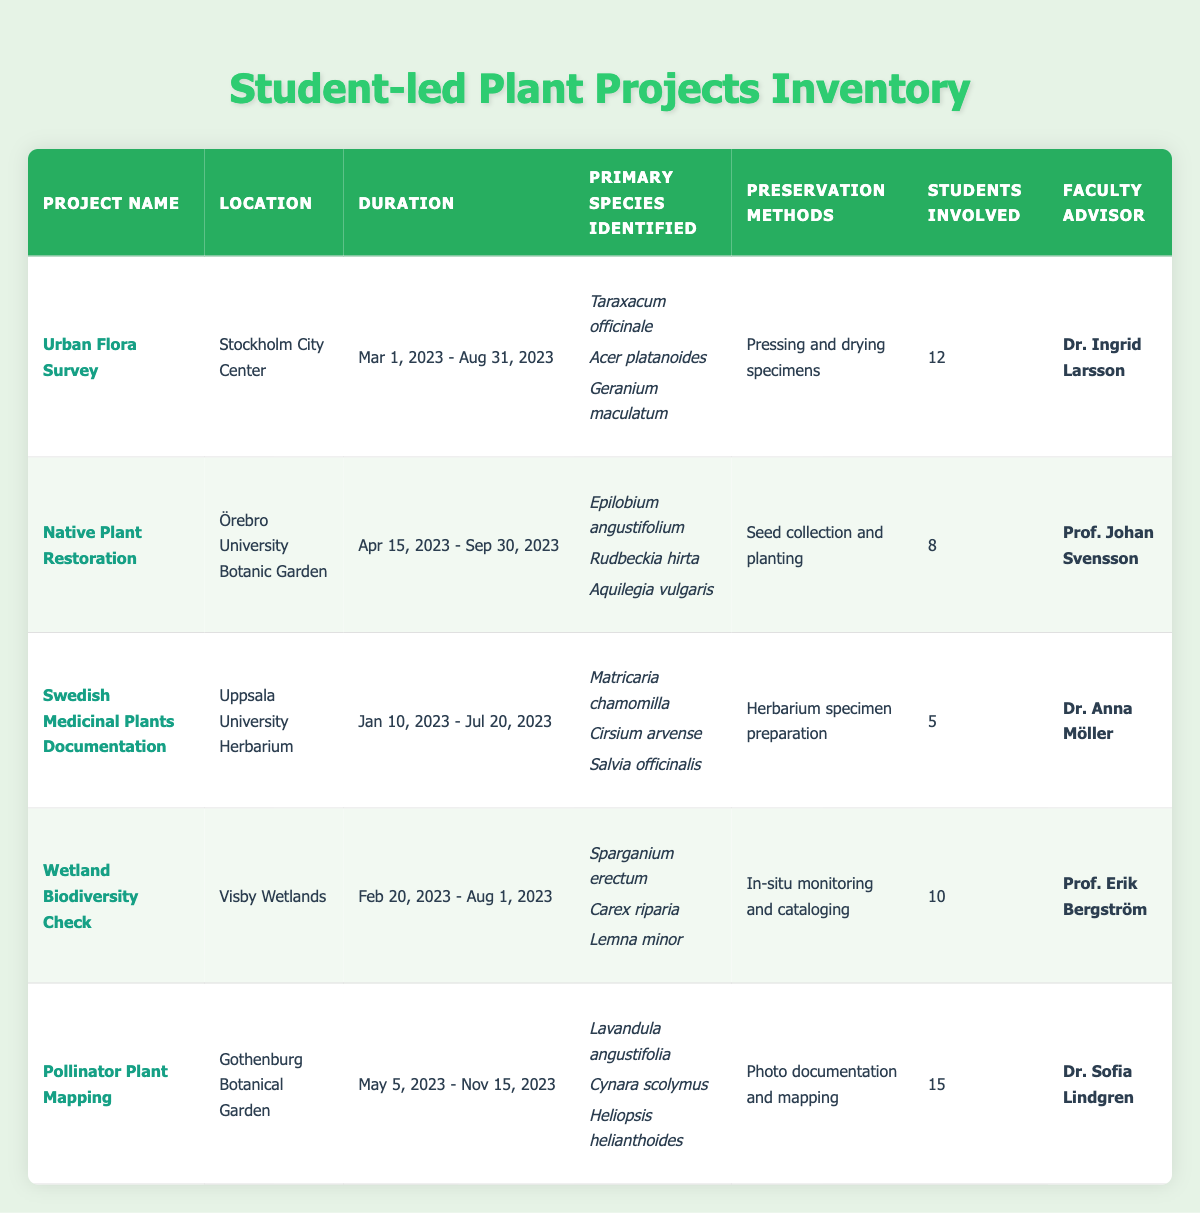What is the primary species identified in the "Pollinator Plant Mapping" project? The "Pollinator Plant Mapping" project lists the primary species identified as follows: Lavandula angustifolia, Cynara scolymus, and Heliopsis helianthoides. We can find this information directly in the corresponding row of the table under "Primary Species Identified."
Answer: Lavandula angustifolia, Cynara scolymus, Heliopsis helianthoides How many students were involved in the "Wetland Biodiversity Check" project? In the "Wetland Biodiversity Check" project, the number of students involved is stated in the table under the "Students Involved" column as 10.
Answer: 10 Which project has the longest duration? To determine which project has the longest duration, we can examine the start and end dates for each project. The "Pollinator Plant Mapping" project lasts from May 5, 2023, to November 15, 2023, a total of 6 months and 10 days. When compared to the other projects, none exceed this duration.
Answer: Pollinator Plant Mapping Are there more students involved in the "Native Plant Restoration" project than in the "Swedish Medicinal Plants Documentation" project? The "Native Plant Restoration" project has 8 students involved, while the "Swedish Medicinal Plants Documentation" project has only 5 students. Since 8 is greater than 5, the answer is yes.
Answer: Yes What is the average number of students involved across all projects? To find the average number of students, we sum up the number of students involved in each project: 12 + 8 + 5 + 10 + 15 = 50. There are 5 projects, so we divide the total by 5: 50 / 5 = 10.
Answer: 10 Is the faculty advisor for the "Urban Flora Survey" project the same as for the "Wetland Biodiversity Check" project? The "Urban Flora Survey" project has Dr. Ingrid Larsson as the faculty advisor, while the "Wetland Biodiversity Check" project has Prof. Erik Bergström. Since the names are different, the answer is no.
Answer: No What preservation method is used in the "Swedish Medicinal Plants Documentation" project? The preservation method for the "Swedish Medicinal Plants Documentation" project is listed as "Herbarium specimen preparation." This information can be found in the corresponding row of the table.
Answer: Herbarium specimen preparation Which location has the least number of students involved across its projects? Examining the student involvement in each project: Stockholm City Center has 12, Örebro University Botanic Garden has 8, Uppsala University Herbarium has 5, Visby Wetlands has 10, and Gothenburg Botanical Garden has 15. The location with the least involvement is the Uppsala University Herbarium with only 5 students.
Answer: Uppsala University Herbarium 